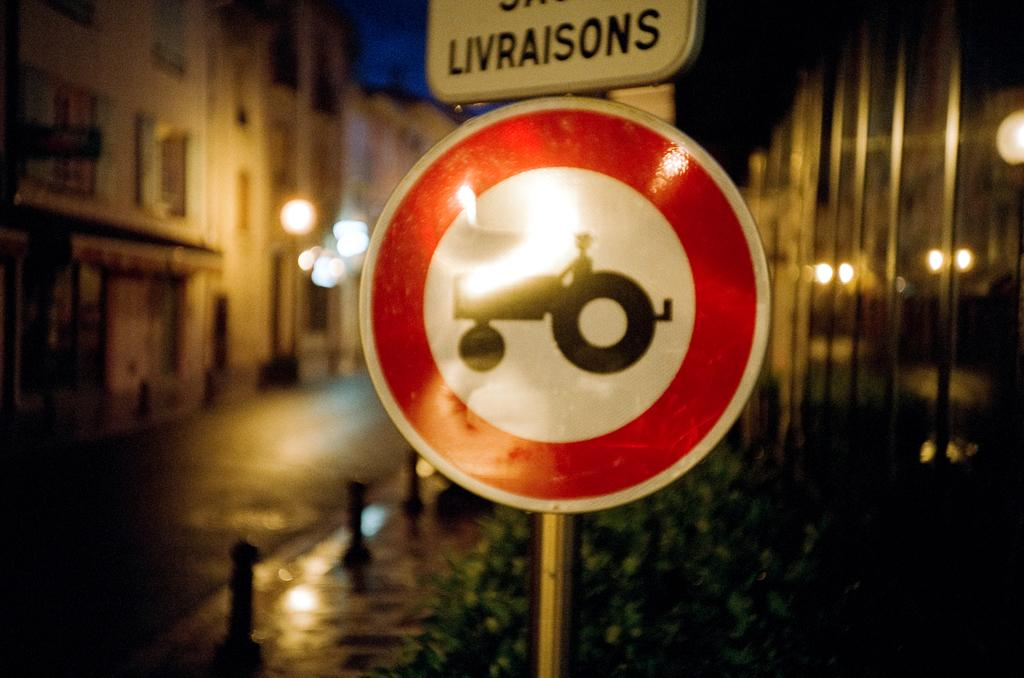<image>
Give a short and clear explanation of the subsequent image. a sign that says livraisons at the top of it 